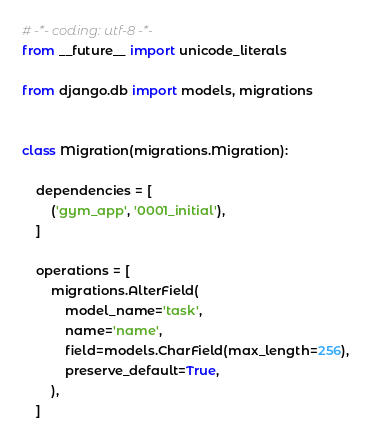Convert code to text. <code><loc_0><loc_0><loc_500><loc_500><_Python_># -*- coding: utf-8 -*-
from __future__ import unicode_literals

from django.db import models, migrations


class Migration(migrations.Migration):

    dependencies = [
        ('gym_app', '0001_initial'),
    ]

    operations = [
        migrations.AlterField(
            model_name='task',
            name='name',
            field=models.CharField(max_length=256),
            preserve_default=True,
        ),
    ]
</code> 